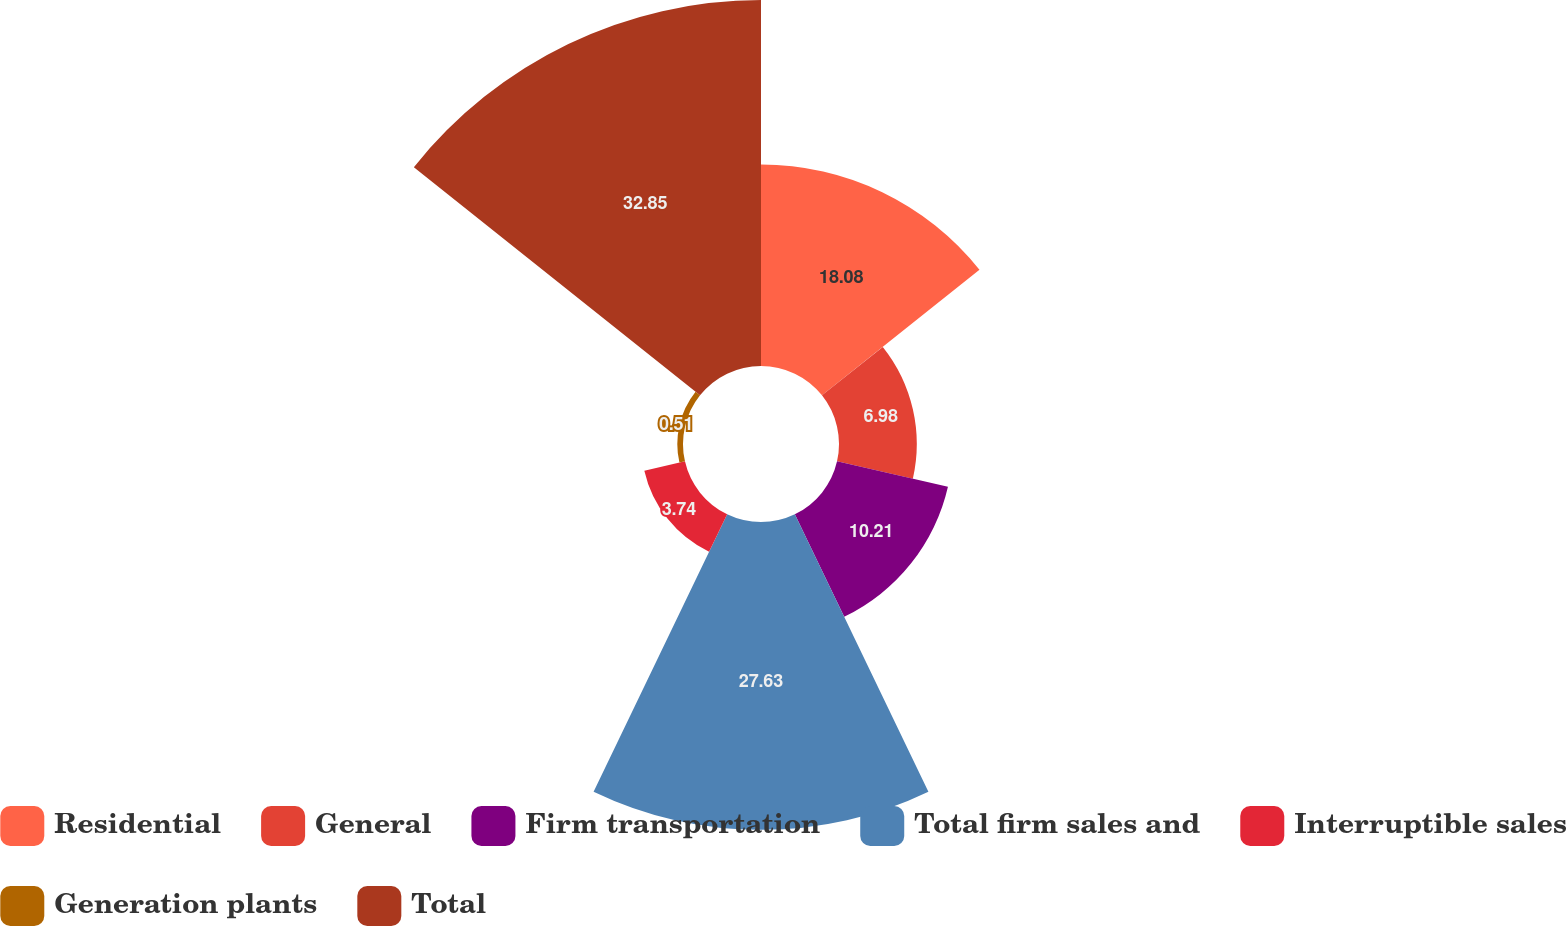Convert chart to OTSL. <chart><loc_0><loc_0><loc_500><loc_500><pie_chart><fcel>Residential<fcel>General<fcel>Firm transportation<fcel>Total firm sales and<fcel>Interruptible sales<fcel>Generation plants<fcel>Total<nl><fcel>18.08%<fcel>6.98%<fcel>10.21%<fcel>27.63%<fcel>3.74%<fcel>0.51%<fcel>32.85%<nl></chart> 